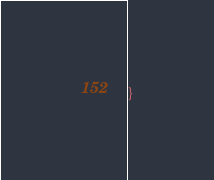Convert code to text. <code><loc_0><loc_0><loc_500><loc_500><_CSS_>}</code> 